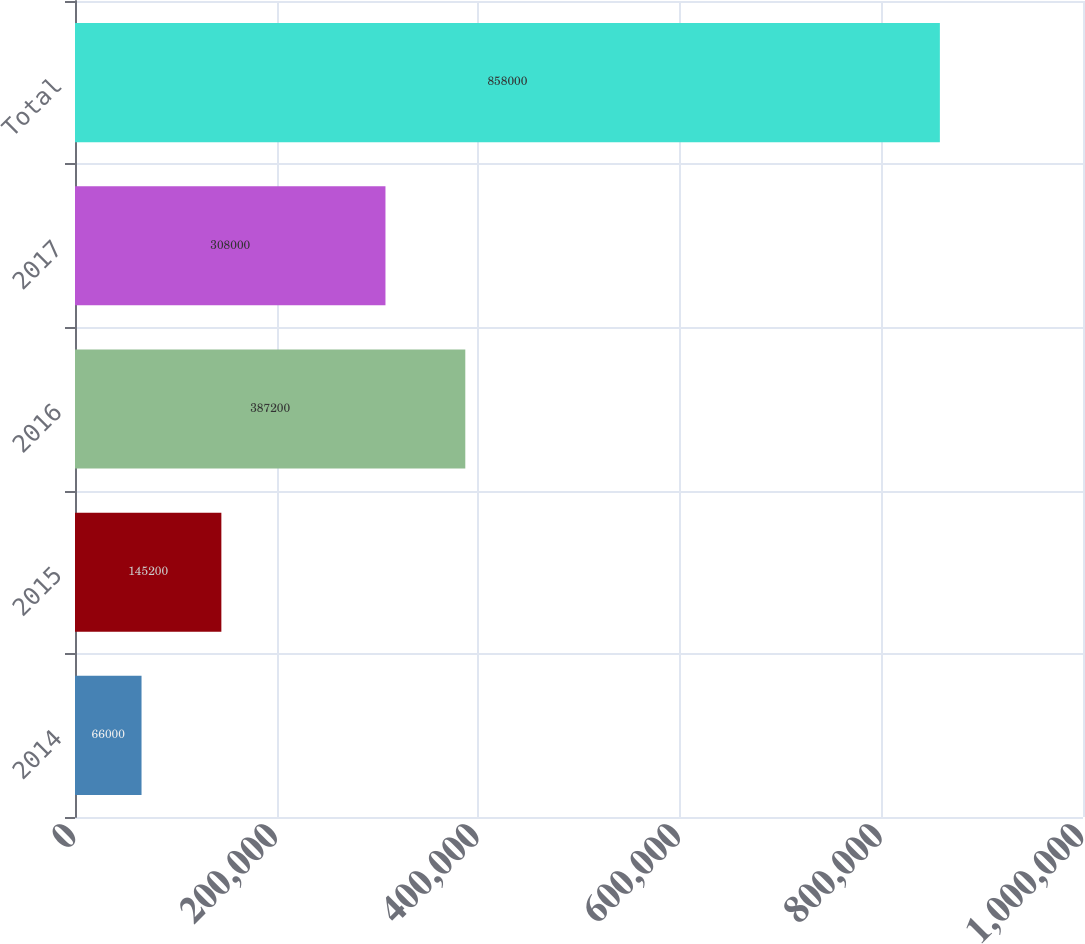Convert chart to OTSL. <chart><loc_0><loc_0><loc_500><loc_500><bar_chart><fcel>2014<fcel>2015<fcel>2016<fcel>2017<fcel>Total<nl><fcel>66000<fcel>145200<fcel>387200<fcel>308000<fcel>858000<nl></chart> 